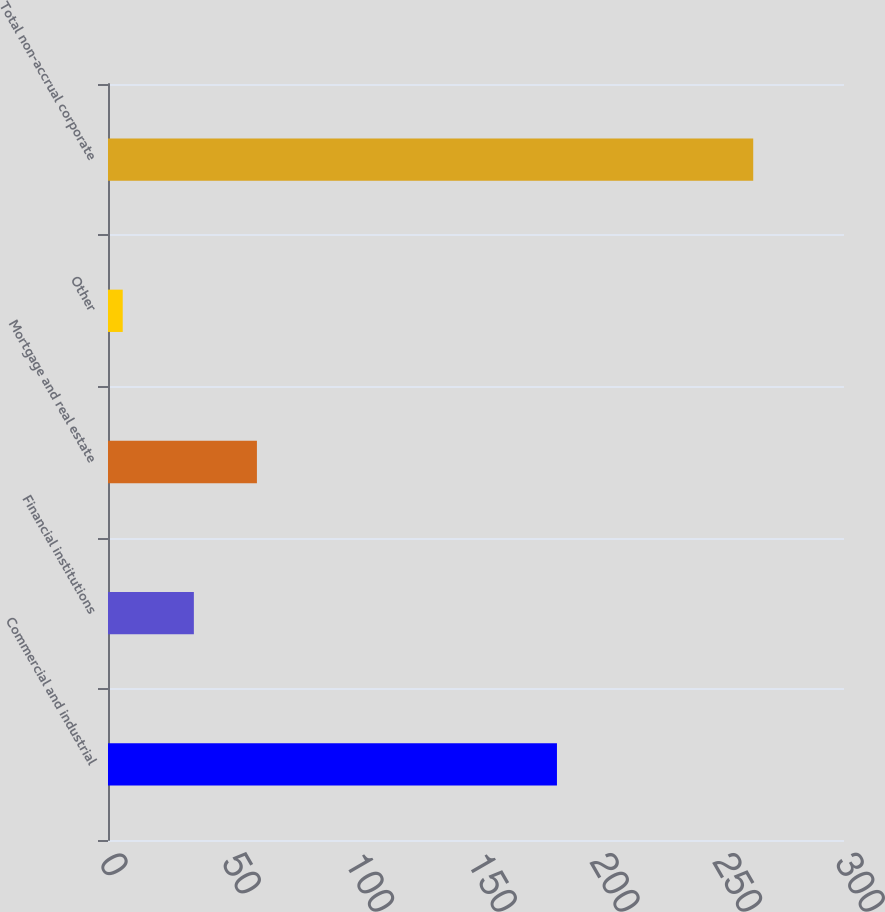<chart> <loc_0><loc_0><loc_500><loc_500><bar_chart><fcel>Commercial and industrial<fcel>Financial institutions<fcel>Mortgage and real estate<fcel>Other<fcel>Total non-accrual corporate<nl><fcel>183<fcel>35<fcel>60.7<fcel>6<fcel>263<nl></chart> 